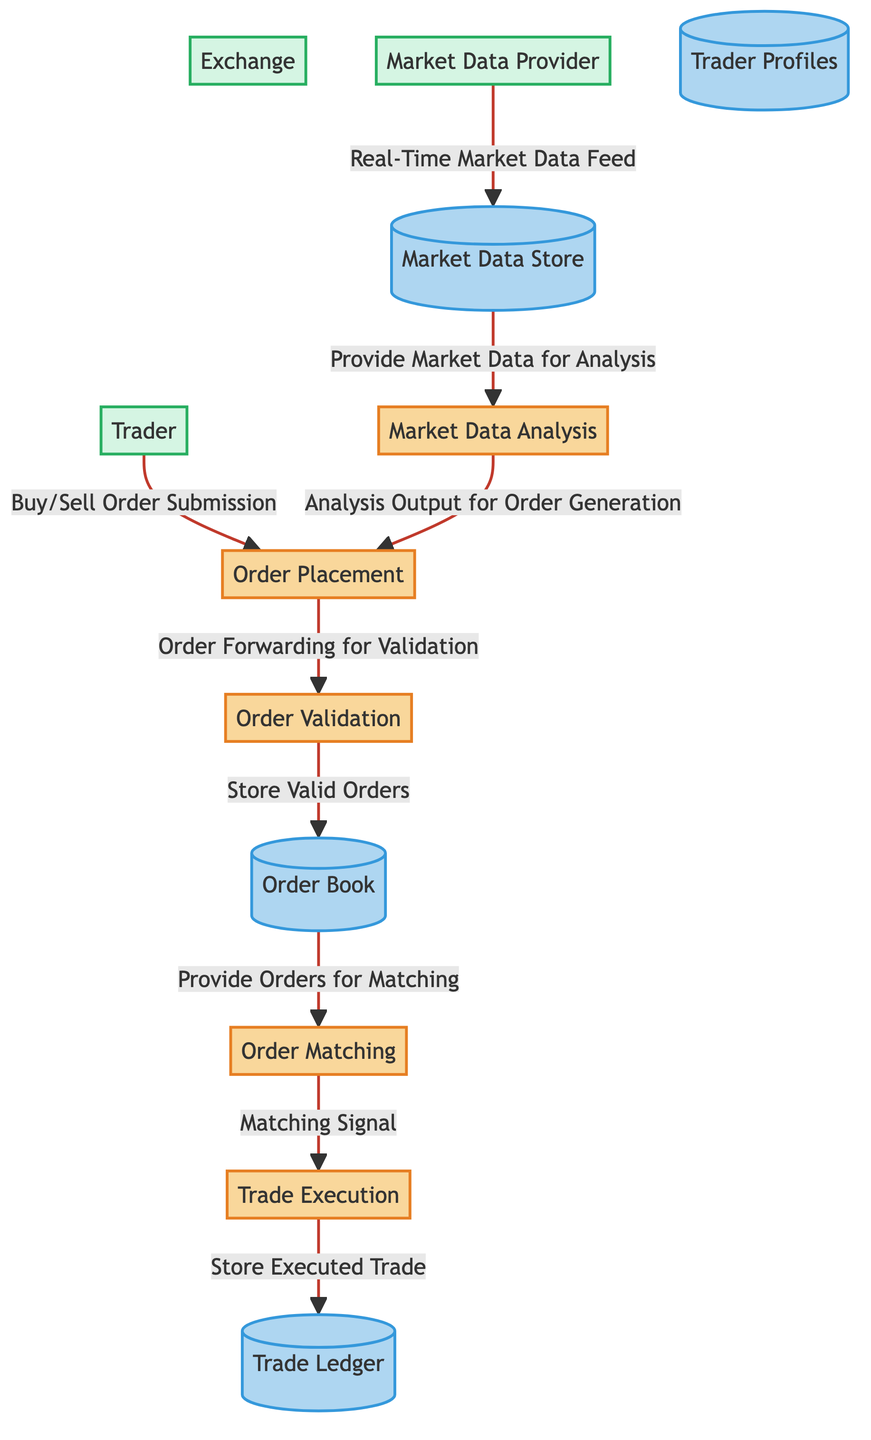What is the first process in the diagram? The diagram starts with the process of Order Placement, which is the initial action where traders or trading algorithms submit buy/sell orders.
Answer: Order Placement How many data stores are present in the diagram? There are four data stores depicted in the diagram, which are the Order Book, Trade Ledger, Market Data Store, and Trader Profiles.
Answer: 4 What type of data does the Order Validation process store? The Order Validation process stores Validated Orders in the Order Book, which contains orders that have passed validation checks.
Answer: Validated Orders Which entity feeds real-time market data into the system? The Market Data Provider is responsible for supplying the real-time market data feed to the Market Data Store in the system.
Answer: Market Data Provider How does Market Data Analysis influence Order Placement? Market Data Analysis provides Market Insights that are utilized in the Order Placement process for generating orders based on analyzed market conditions.
Answer: Market Insights What is the relationship between Order Matching and Trade Execution? The Order Matching process provides a Matching Signal to the Trade Execution process, indicating which orders have been successfully matched for execution.
Answer: Matching Signal What data flow takes place from the Market Data Store to Market Data Analysis? The Market Data Store provides Market Data for Analysis to the Market Data Analysis process, allowing it to evaluate incoming market information.
Answer: Market Data Which data store records all executed trades? The Trade Ledger is the designated data store that keeps a detailed record of all executed trades that occur in the system.
Answer: Trade Ledger What is the final output of the Trade Execution process? The final output of the Trade Execution process is stored in the Trade Ledger as Executed Trade Details, indicating completed trades.
Answer: Executed Trade Details 